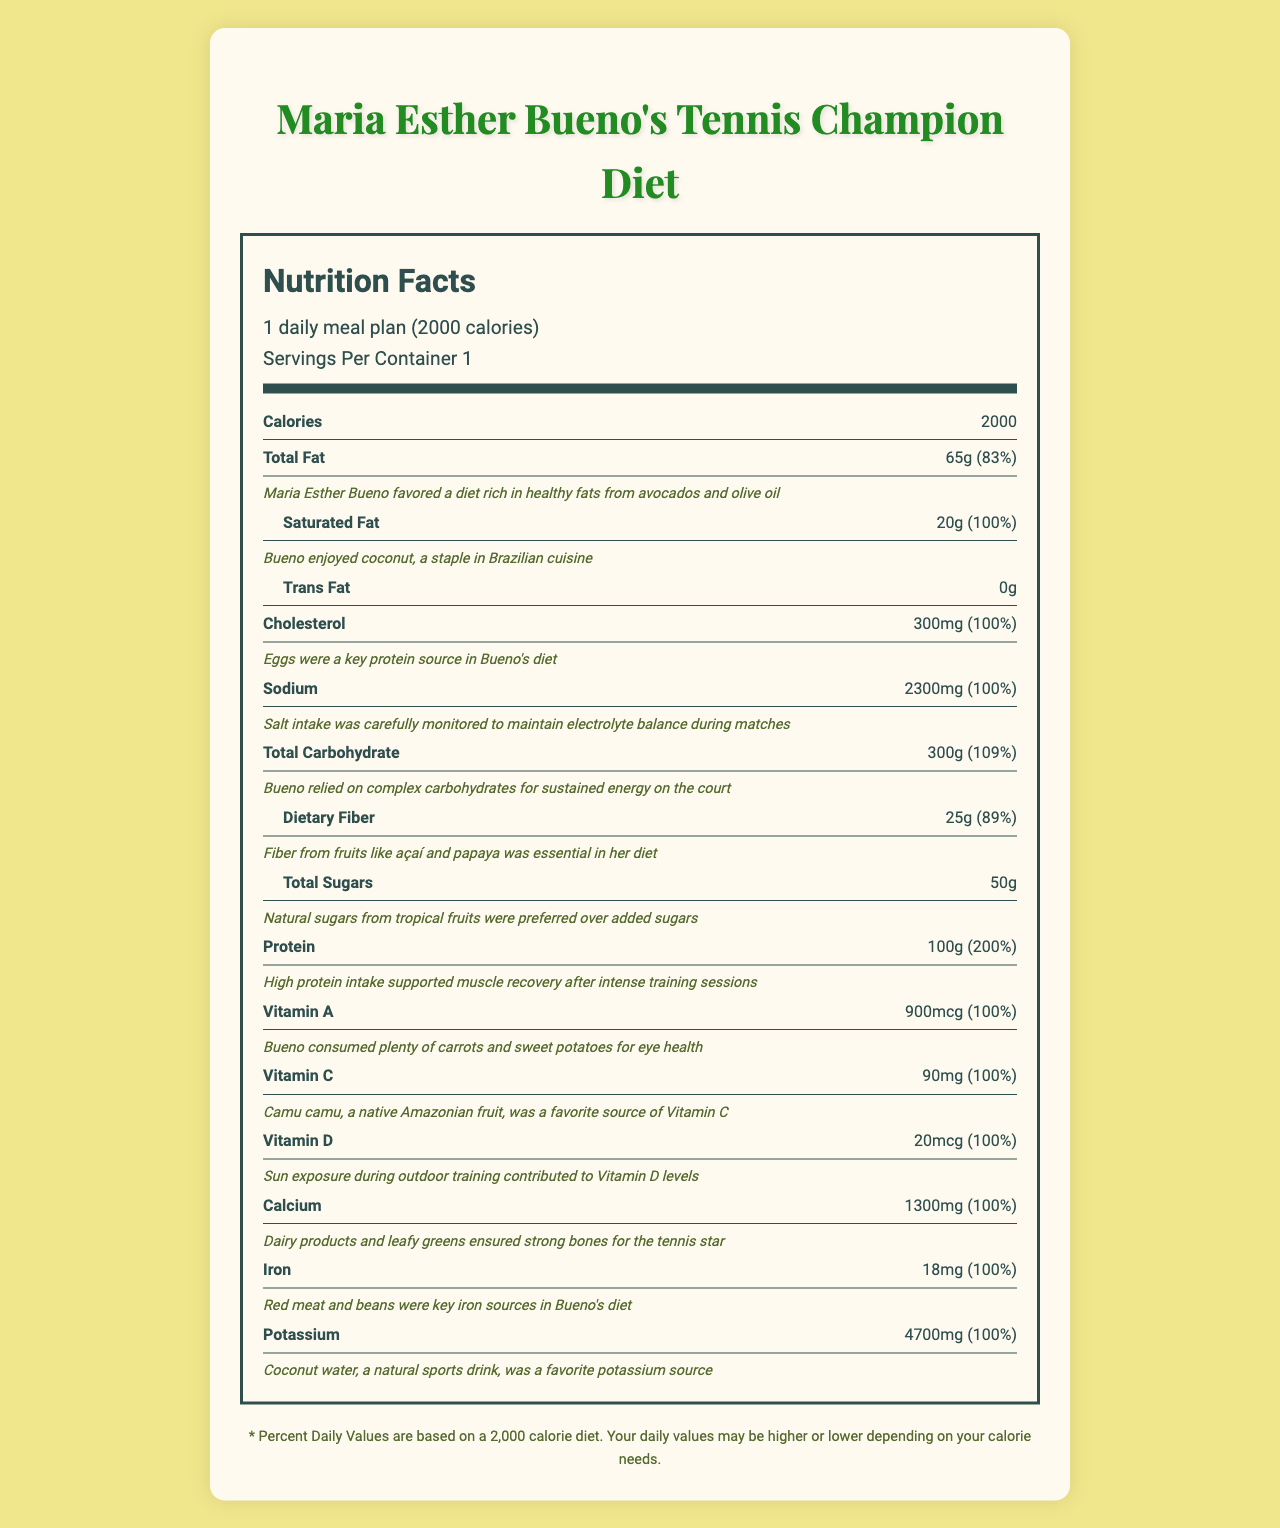what is the serving size? The serving size is explicitly mentioned as "1 daily meal plan (2000 calories)" at the top of the document.
Answer: 1 daily meal plan (2000 calories) what food sources contributed to Maria Esther Bueno's fiber intake? The note attached to the dietary fiber section mentions that fiber came from fruits like açaí and papaya.
Answer: Fruits like açaí and papaya how many grams of protein did she consume daily? The nutrition label lists protein as 100g.
Answer: 100g what is the percentage of daily value for total carbohydrate? The daily value percentage for total carbohydrate is listed as 109%.
Answer: 109% what mineral is provided by brazil nuts in Bueno's diet? The notes indicate that Brazil nuts, which are native to the Amazon, were an excellent source of selenium.
Answer: Selenium how did Bueno obtain her vitamin D? The note for vitamin D states that sun exposure during outdoor training contributed to her vitamin D levels.
Answer: Sun exposure during outdoor training which nutrient listed does not have a percentage daily value? A. Trans Fat B. Sodium C. Potassium D. Dietary Fiber Trans Fat does not have a percentage daily value listed.
Answer: A from which tropical fruit did Bueno prefer to get her sugars? A. Mango B. Guava C. Pineapple D. Coconut E. No specific tropical fruit is mentioned The notes mention natural sugars from tropical fruits were preferred but do not specify a particular fruit.
Answer: E did Bueno’s diet achieve 100% of the daily value for Vitamin C? The document states that Bueno consumed 90mg of Vitamin C, which is 100% of the daily value.
Answer: Yes describe the main theme of this document. The document provides a detailed breakdown of essential vitamins, minerals, and other nutrients in Maria Esther Bueno's diet along with their sources.
Answer: It outlines the nutrition facts and food sources of Maria Esther Bueno's daily meal plan used to support her tennis career. how many daily calories did Bueno consume? The document mentions a daily meal plan consisting of 2000 calories at the top of the page.
Answer: 2000 calories did Bueno consume trans fats in her diet? The document states that the amount of trans fat is 0g.
Answer: No what foods did Bueno use to get zinc? A. Fish B. Oysters C. Beef D. Eggs The notes specify that oysters and other seafood were part of her diet for boosting zinc intake.
Answer: B how much iodine did Bueno ingest daily? The nutrition label lists the amount of iodine as 150mcg.
Answer: 150mcg which of the following foods was NOT mentioned as part of Bueno's intake? A. Avocados B. Fish C. Lettuce D. Eggs Lettuce is not mentioned in the document; the notes frequently reference other specific foods.
Answer: C are protein and dietary fiber amounts given as a percentage daily value? Both protein and dietary fiber have percentage daily values: 200% for protein and 89% for dietary fiber.
Answer: Yes is there any information on how Bueno's diet balanced chloride for proper hydration? The note under chloride mentions it was balanced with sodium for proper hydration during matches.
Answer: Yes how much potassium is provided daily in her diet? The document lists the potassium amount as 4700mg.
Answer: 4700mg what food was a staple in Bueno’s diet providing folate? The notes mention that black beans, a staple in feijoada, provided folate.
Answer: Black beans what is the exact amount of daily cholesterol intake? The cholesterol amount is listed as 300mg.
Answer: 300mg what is the daily value percentage for iron in Bueno’s diet? The document lists that the daily value percentage for iron intake is 100%.
Answer: 100% from which specific fruit did Bueno get most of her vitamin C? The note for vitamin C points to camu camu as her favorite source.
Answer: Camu camu 